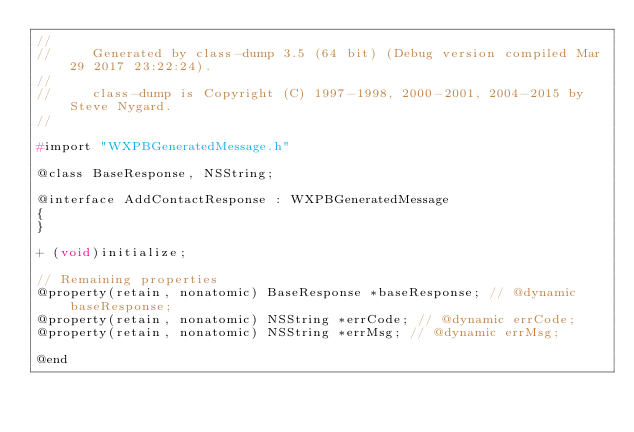Convert code to text. <code><loc_0><loc_0><loc_500><loc_500><_C_>//
//     Generated by class-dump 3.5 (64 bit) (Debug version compiled Mar 29 2017 23:22:24).
//
//     class-dump is Copyright (C) 1997-1998, 2000-2001, 2004-2015 by Steve Nygard.
//

#import "WXPBGeneratedMessage.h"

@class BaseResponse, NSString;

@interface AddContactResponse : WXPBGeneratedMessage
{
}

+ (void)initialize;

// Remaining properties
@property(retain, nonatomic) BaseResponse *baseResponse; // @dynamic baseResponse;
@property(retain, nonatomic) NSString *errCode; // @dynamic errCode;
@property(retain, nonatomic) NSString *errMsg; // @dynamic errMsg;

@end

</code> 